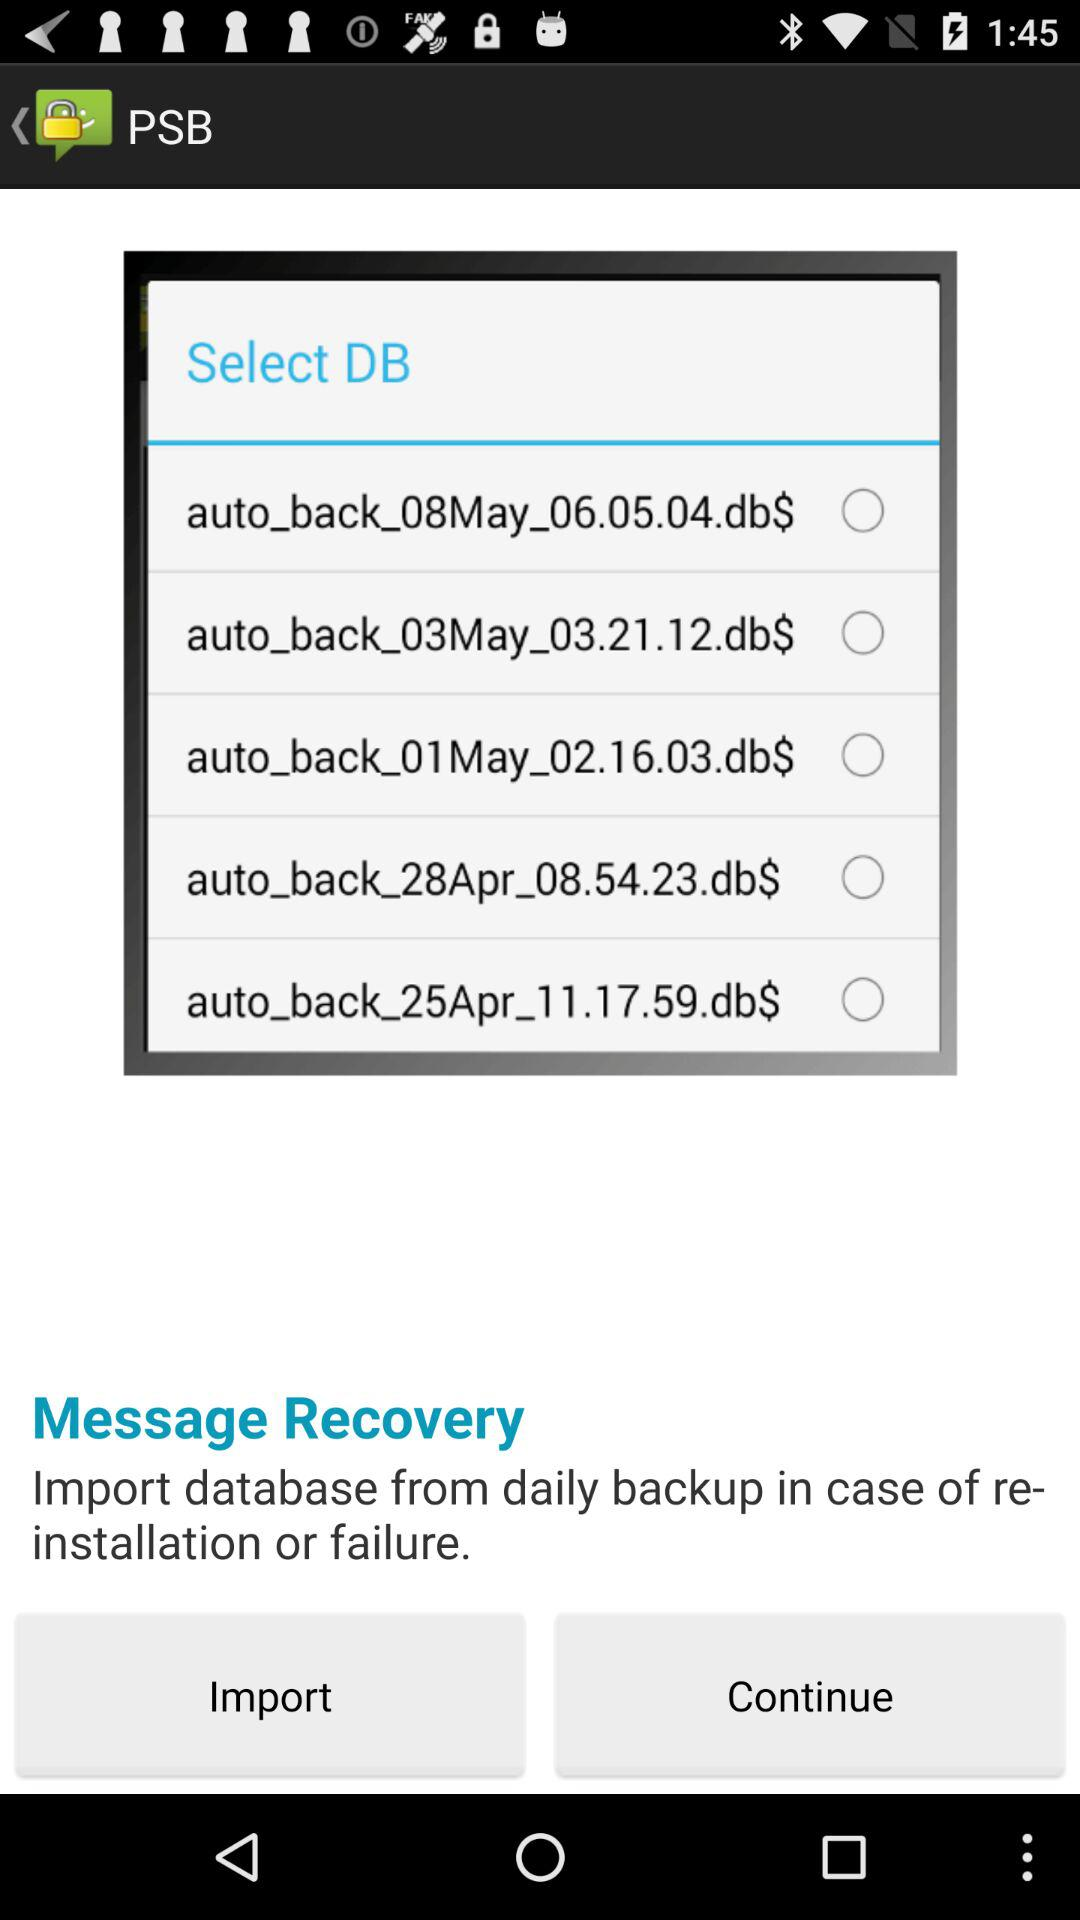How many backup files are available for selection?
Answer the question using a single word or phrase. 5 